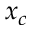<formula> <loc_0><loc_0><loc_500><loc_500>x _ { c }</formula> 